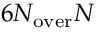Convert formula to latex. <formula><loc_0><loc_0><loc_500><loc_500>6 N _ { o v e r } N</formula> 